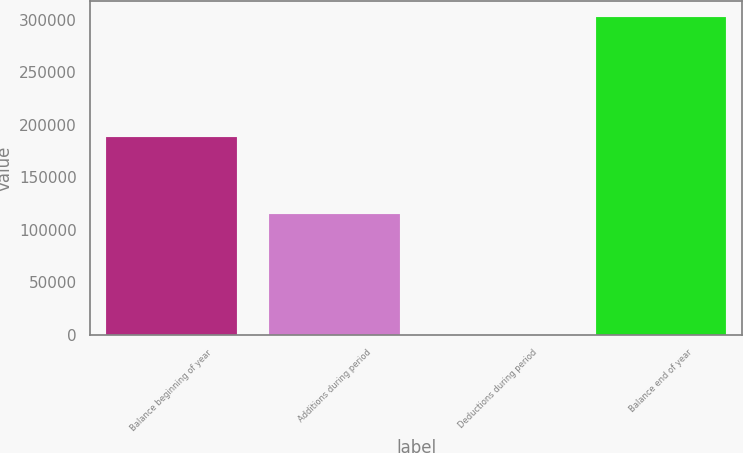Convert chart to OTSL. <chart><loc_0><loc_0><loc_500><loc_500><bar_chart><fcel>Balance beginning of year<fcel>Additions during period<fcel>Deductions during period<fcel>Balance end of year<nl><fcel>188099<fcel>115158<fcel>421<fcel>302836<nl></chart> 